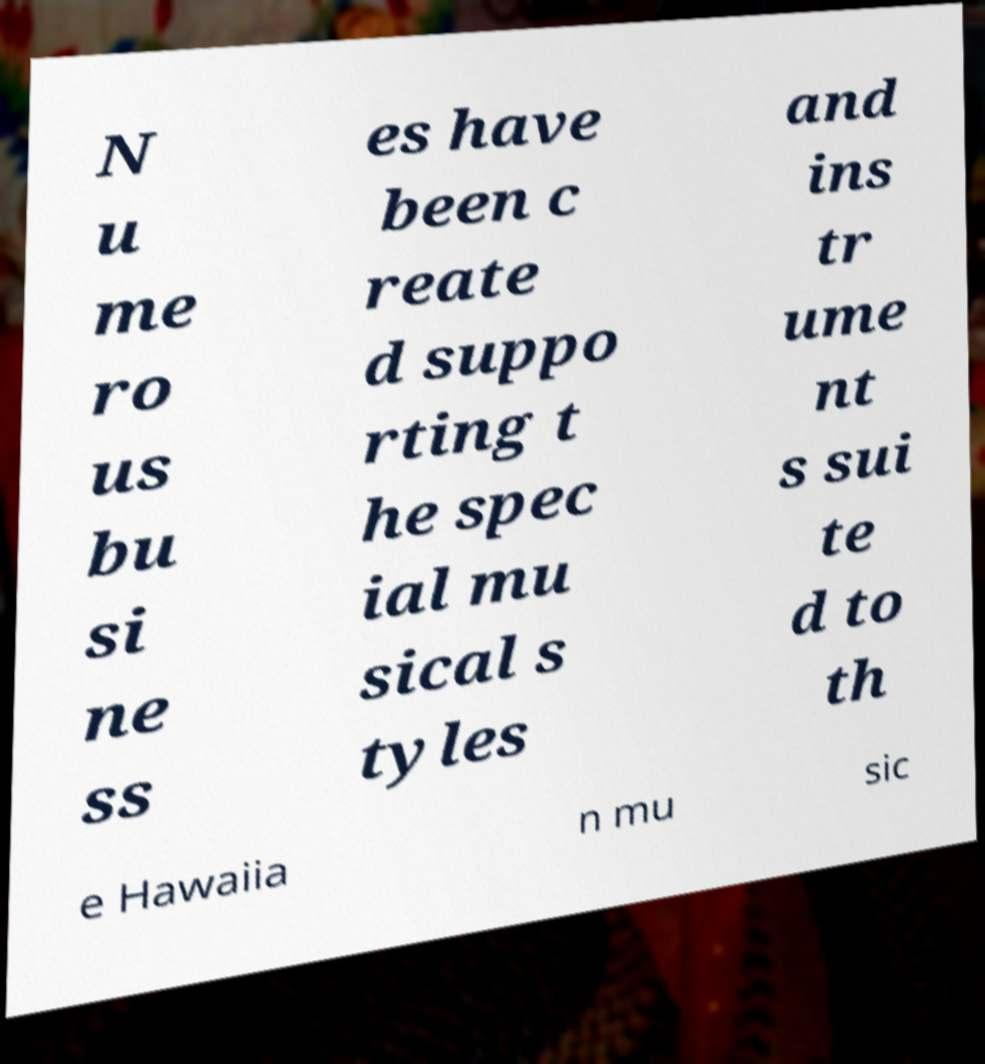Could you assist in decoding the text presented in this image and type it out clearly? N u me ro us bu si ne ss es have been c reate d suppo rting t he spec ial mu sical s tyles and ins tr ume nt s sui te d to th e Hawaiia n mu sic 